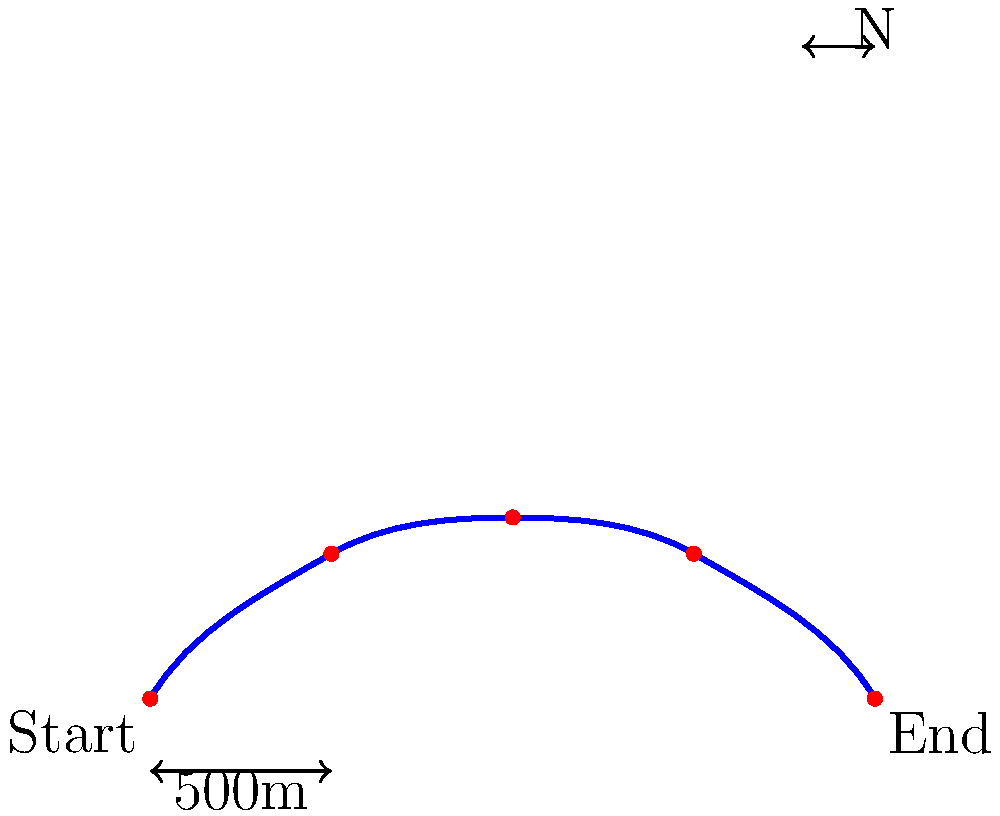Given the GPS track visualization of a hiking trail, estimate the total distance hiked. The scale indicates that 50 units on the graph represent 500 meters. Round your answer to the nearest 100 meters. To estimate the total distance hiked, we'll follow these steps:

1. Observe that the trail is composed of four segments between five GPS points.

2. Estimate the length of each segment in graph units:
   - Segment 1: approximately 70 units
   - Segment 2: approximately 50 units
   - Segment 3: approximately 50 units
   - Segment 4: approximately 60 units

3. Sum up the total length in graph units:
   $70 + 50 + 50 + 60 = 230$ units

4. Use the given scale to convert graph units to meters:
   If 50 units = 500 meters, then 1 unit = 10 meters

5. Calculate the total distance in meters:
   $230 \times 10 = 2300$ meters

6. Round to the nearest 100 meters:
   2300 meters rounds to 2300 meters

Therefore, the estimated total distance hiked is 2300 meters or 2.3 kilometers.
Answer: 2300 meters 